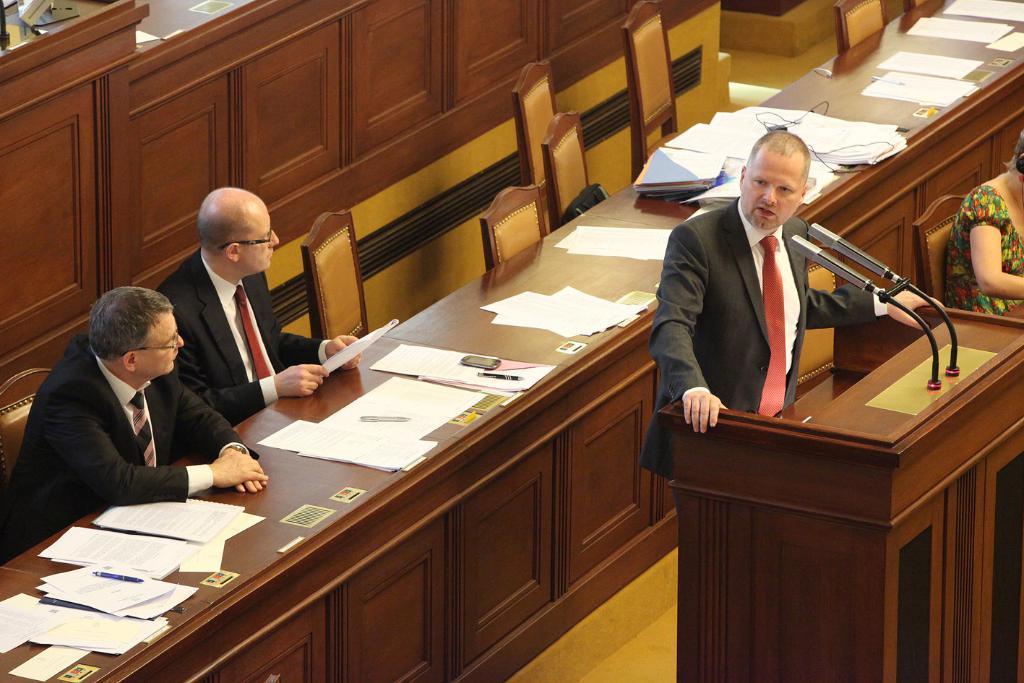Please provide a concise description of this image. The image is inside a conference hall. In the image in middle of the hall there is a man who is standing in front of a microphone holding a table and opened his mouth for talking. On right side there is a woman who is sitting chair. On left side there are two mans one man is holding a paper and sitting on chair, another man is also sitting on chair behind the table. On table we can see paper,pen,books,wires. 